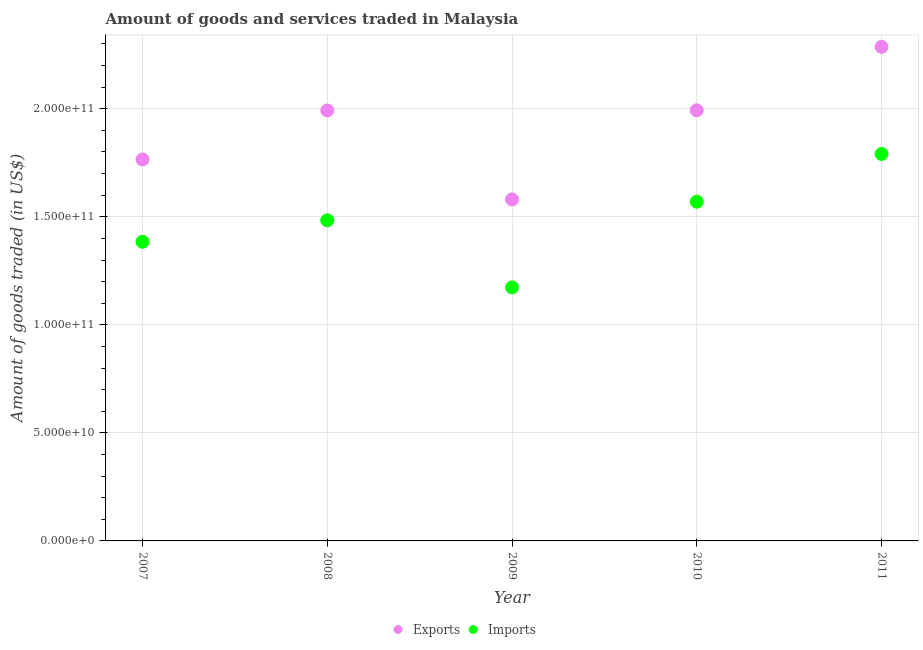How many different coloured dotlines are there?
Make the answer very short. 2. Is the number of dotlines equal to the number of legend labels?
Your answer should be compact. Yes. What is the amount of goods imported in 2010?
Offer a very short reply. 1.57e+11. Across all years, what is the maximum amount of goods imported?
Provide a short and direct response. 1.79e+11. Across all years, what is the minimum amount of goods imported?
Make the answer very short. 1.17e+11. In which year was the amount of goods exported maximum?
Provide a short and direct response. 2011. What is the total amount of goods imported in the graph?
Offer a terse response. 7.40e+11. What is the difference between the amount of goods imported in 2008 and that in 2010?
Ensure brevity in your answer.  -8.60e+09. What is the difference between the amount of goods imported in 2011 and the amount of goods exported in 2010?
Provide a succinct answer. -2.02e+1. What is the average amount of goods exported per year?
Provide a short and direct response. 1.92e+11. In the year 2010, what is the difference between the amount of goods exported and amount of goods imported?
Provide a short and direct response. 4.23e+1. In how many years, is the amount of goods exported greater than 20000000000 US$?
Your response must be concise. 5. What is the ratio of the amount of goods exported in 2007 to that in 2011?
Provide a succinct answer. 0.77. Is the amount of goods exported in 2008 less than that in 2010?
Give a very brief answer. Yes. Is the difference between the amount of goods imported in 2008 and 2011 greater than the difference between the amount of goods exported in 2008 and 2011?
Your answer should be compact. No. What is the difference between the highest and the second highest amount of goods exported?
Your answer should be very brief. 2.93e+1. What is the difference between the highest and the lowest amount of goods exported?
Give a very brief answer. 7.06e+1. In how many years, is the amount of goods imported greater than the average amount of goods imported taken over all years?
Offer a terse response. 3. Is the amount of goods imported strictly greater than the amount of goods exported over the years?
Your answer should be very brief. No. How many years are there in the graph?
Ensure brevity in your answer.  5. What is the difference between two consecutive major ticks on the Y-axis?
Ensure brevity in your answer.  5.00e+1. Does the graph contain any zero values?
Your answer should be very brief. No. Where does the legend appear in the graph?
Give a very brief answer. Bottom center. How are the legend labels stacked?
Offer a terse response. Horizontal. What is the title of the graph?
Offer a very short reply. Amount of goods and services traded in Malaysia. Does "Study and work" appear as one of the legend labels in the graph?
Offer a terse response. No. What is the label or title of the X-axis?
Provide a succinct answer. Year. What is the label or title of the Y-axis?
Your answer should be compact. Amount of goods traded (in US$). What is the Amount of goods traded (in US$) in Exports in 2007?
Provide a succinct answer. 1.77e+11. What is the Amount of goods traded (in US$) of Imports in 2007?
Your response must be concise. 1.38e+11. What is the Amount of goods traded (in US$) of Exports in 2008?
Your answer should be very brief. 1.99e+11. What is the Amount of goods traded (in US$) of Imports in 2008?
Your answer should be compact. 1.48e+11. What is the Amount of goods traded (in US$) in Exports in 2009?
Provide a short and direct response. 1.58e+11. What is the Amount of goods traded (in US$) in Imports in 2009?
Keep it short and to the point. 1.17e+11. What is the Amount of goods traded (in US$) of Exports in 2010?
Provide a succinct answer. 1.99e+11. What is the Amount of goods traded (in US$) of Imports in 2010?
Provide a succinct answer. 1.57e+11. What is the Amount of goods traded (in US$) of Exports in 2011?
Offer a terse response. 2.29e+11. What is the Amount of goods traded (in US$) in Imports in 2011?
Ensure brevity in your answer.  1.79e+11. Across all years, what is the maximum Amount of goods traded (in US$) of Exports?
Provide a succinct answer. 2.29e+11. Across all years, what is the maximum Amount of goods traded (in US$) of Imports?
Make the answer very short. 1.79e+11. Across all years, what is the minimum Amount of goods traded (in US$) in Exports?
Give a very brief answer. 1.58e+11. Across all years, what is the minimum Amount of goods traded (in US$) of Imports?
Offer a very short reply. 1.17e+11. What is the total Amount of goods traded (in US$) in Exports in the graph?
Your response must be concise. 9.62e+11. What is the total Amount of goods traded (in US$) in Imports in the graph?
Your answer should be very brief. 7.40e+11. What is the difference between the Amount of goods traded (in US$) of Exports in 2007 and that in 2008?
Keep it short and to the point. -2.27e+1. What is the difference between the Amount of goods traded (in US$) of Imports in 2007 and that in 2008?
Make the answer very short. -9.96e+09. What is the difference between the Amount of goods traded (in US$) in Exports in 2007 and that in 2009?
Provide a short and direct response. 1.85e+1. What is the difference between the Amount of goods traded (in US$) in Imports in 2007 and that in 2009?
Keep it short and to the point. 2.11e+1. What is the difference between the Amount of goods traded (in US$) of Exports in 2007 and that in 2010?
Provide a succinct answer. -2.28e+1. What is the difference between the Amount of goods traded (in US$) of Imports in 2007 and that in 2010?
Provide a succinct answer. -1.86e+1. What is the difference between the Amount of goods traded (in US$) of Exports in 2007 and that in 2011?
Provide a succinct answer. -5.21e+1. What is the difference between the Amount of goods traded (in US$) of Imports in 2007 and that in 2011?
Offer a very short reply. -4.07e+1. What is the difference between the Amount of goods traded (in US$) in Exports in 2008 and that in 2009?
Offer a very short reply. 4.12e+1. What is the difference between the Amount of goods traded (in US$) of Imports in 2008 and that in 2009?
Make the answer very short. 3.11e+1. What is the difference between the Amount of goods traded (in US$) in Exports in 2008 and that in 2010?
Offer a terse response. -7.30e+07. What is the difference between the Amount of goods traded (in US$) in Imports in 2008 and that in 2010?
Give a very brief answer. -8.60e+09. What is the difference between the Amount of goods traded (in US$) of Exports in 2008 and that in 2011?
Your response must be concise. -2.94e+1. What is the difference between the Amount of goods traded (in US$) in Imports in 2008 and that in 2011?
Give a very brief answer. -3.07e+1. What is the difference between the Amount of goods traded (in US$) in Exports in 2009 and that in 2010?
Provide a short and direct response. -4.12e+1. What is the difference between the Amount of goods traded (in US$) in Imports in 2009 and that in 2010?
Make the answer very short. -3.97e+1. What is the difference between the Amount of goods traded (in US$) of Exports in 2009 and that in 2011?
Make the answer very short. -7.06e+1. What is the difference between the Amount of goods traded (in US$) in Imports in 2009 and that in 2011?
Provide a succinct answer. -6.18e+1. What is the difference between the Amount of goods traded (in US$) in Exports in 2010 and that in 2011?
Ensure brevity in your answer.  -2.93e+1. What is the difference between the Amount of goods traded (in US$) in Imports in 2010 and that in 2011?
Your answer should be very brief. -2.21e+1. What is the difference between the Amount of goods traded (in US$) in Exports in 2007 and the Amount of goods traded (in US$) in Imports in 2008?
Offer a very short reply. 2.82e+1. What is the difference between the Amount of goods traded (in US$) in Exports in 2007 and the Amount of goods traded (in US$) in Imports in 2009?
Make the answer very short. 5.92e+1. What is the difference between the Amount of goods traded (in US$) of Exports in 2007 and the Amount of goods traded (in US$) of Imports in 2010?
Your response must be concise. 1.96e+1. What is the difference between the Amount of goods traded (in US$) of Exports in 2007 and the Amount of goods traded (in US$) of Imports in 2011?
Make the answer very short. -2.54e+09. What is the difference between the Amount of goods traded (in US$) of Exports in 2008 and the Amount of goods traded (in US$) of Imports in 2009?
Keep it short and to the point. 8.19e+1. What is the difference between the Amount of goods traded (in US$) in Exports in 2008 and the Amount of goods traded (in US$) in Imports in 2010?
Provide a succinct answer. 4.22e+1. What is the difference between the Amount of goods traded (in US$) in Exports in 2008 and the Amount of goods traded (in US$) in Imports in 2011?
Provide a short and direct response. 2.01e+1. What is the difference between the Amount of goods traded (in US$) of Exports in 2009 and the Amount of goods traded (in US$) of Imports in 2010?
Offer a terse response. 1.06e+09. What is the difference between the Amount of goods traded (in US$) of Exports in 2009 and the Amount of goods traded (in US$) of Imports in 2011?
Ensure brevity in your answer.  -2.10e+1. What is the difference between the Amount of goods traded (in US$) in Exports in 2010 and the Amount of goods traded (in US$) in Imports in 2011?
Provide a succinct answer. 2.02e+1. What is the average Amount of goods traded (in US$) of Exports per year?
Your answer should be compact. 1.92e+11. What is the average Amount of goods traded (in US$) of Imports per year?
Keep it short and to the point. 1.48e+11. In the year 2007, what is the difference between the Amount of goods traded (in US$) in Exports and Amount of goods traded (in US$) in Imports?
Make the answer very short. 3.81e+1. In the year 2008, what is the difference between the Amount of goods traded (in US$) of Exports and Amount of goods traded (in US$) of Imports?
Ensure brevity in your answer.  5.08e+1. In the year 2009, what is the difference between the Amount of goods traded (in US$) of Exports and Amount of goods traded (in US$) of Imports?
Give a very brief answer. 4.07e+1. In the year 2010, what is the difference between the Amount of goods traded (in US$) of Exports and Amount of goods traded (in US$) of Imports?
Provide a short and direct response. 4.23e+1. In the year 2011, what is the difference between the Amount of goods traded (in US$) in Exports and Amount of goods traded (in US$) in Imports?
Provide a short and direct response. 4.95e+1. What is the ratio of the Amount of goods traded (in US$) in Exports in 2007 to that in 2008?
Offer a very short reply. 0.89. What is the ratio of the Amount of goods traded (in US$) in Imports in 2007 to that in 2008?
Keep it short and to the point. 0.93. What is the ratio of the Amount of goods traded (in US$) of Exports in 2007 to that in 2009?
Offer a very short reply. 1.12. What is the ratio of the Amount of goods traded (in US$) of Imports in 2007 to that in 2009?
Provide a succinct answer. 1.18. What is the ratio of the Amount of goods traded (in US$) of Exports in 2007 to that in 2010?
Your answer should be compact. 0.89. What is the ratio of the Amount of goods traded (in US$) of Imports in 2007 to that in 2010?
Your answer should be very brief. 0.88. What is the ratio of the Amount of goods traded (in US$) in Exports in 2007 to that in 2011?
Offer a very short reply. 0.77. What is the ratio of the Amount of goods traded (in US$) of Imports in 2007 to that in 2011?
Ensure brevity in your answer.  0.77. What is the ratio of the Amount of goods traded (in US$) in Exports in 2008 to that in 2009?
Give a very brief answer. 1.26. What is the ratio of the Amount of goods traded (in US$) of Imports in 2008 to that in 2009?
Provide a short and direct response. 1.26. What is the ratio of the Amount of goods traded (in US$) of Exports in 2008 to that in 2010?
Offer a terse response. 1. What is the ratio of the Amount of goods traded (in US$) of Imports in 2008 to that in 2010?
Give a very brief answer. 0.95. What is the ratio of the Amount of goods traded (in US$) in Exports in 2008 to that in 2011?
Keep it short and to the point. 0.87. What is the ratio of the Amount of goods traded (in US$) in Imports in 2008 to that in 2011?
Give a very brief answer. 0.83. What is the ratio of the Amount of goods traded (in US$) of Exports in 2009 to that in 2010?
Your response must be concise. 0.79. What is the ratio of the Amount of goods traded (in US$) in Imports in 2009 to that in 2010?
Provide a succinct answer. 0.75. What is the ratio of the Amount of goods traded (in US$) in Exports in 2009 to that in 2011?
Give a very brief answer. 0.69. What is the ratio of the Amount of goods traded (in US$) of Imports in 2009 to that in 2011?
Give a very brief answer. 0.66. What is the ratio of the Amount of goods traded (in US$) in Exports in 2010 to that in 2011?
Give a very brief answer. 0.87. What is the ratio of the Amount of goods traded (in US$) of Imports in 2010 to that in 2011?
Offer a terse response. 0.88. What is the difference between the highest and the second highest Amount of goods traded (in US$) in Exports?
Keep it short and to the point. 2.93e+1. What is the difference between the highest and the second highest Amount of goods traded (in US$) of Imports?
Your response must be concise. 2.21e+1. What is the difference between the highest and the lowest Amount of goods traded (in US$) in Exports?
Provide a succinct answer. 7.06e+1. What is the difference between the highest and the lowest Amount of goods traded (in US$) of Imports?
Provide a short and direct response. 6.18e+1. 